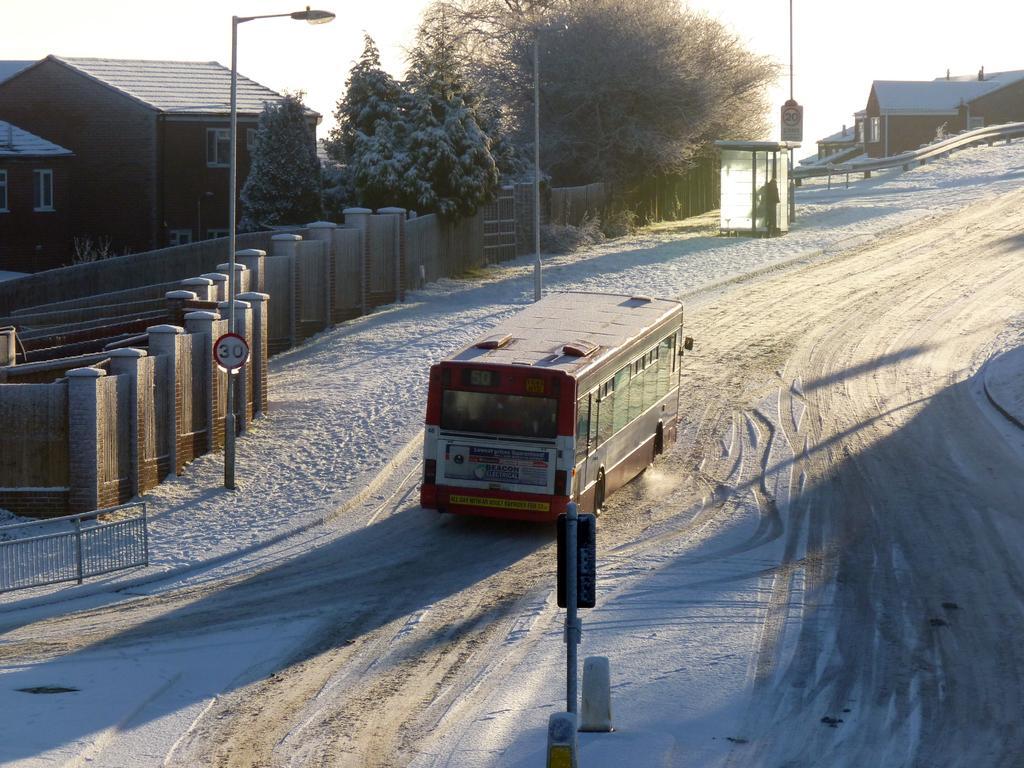Could you give a brief overview of what you see in this image? In this image we can see a vehicle on the ground, there are some houses, trees, poles, lights, boards, railing and the wall, in the background we can see the sky. 